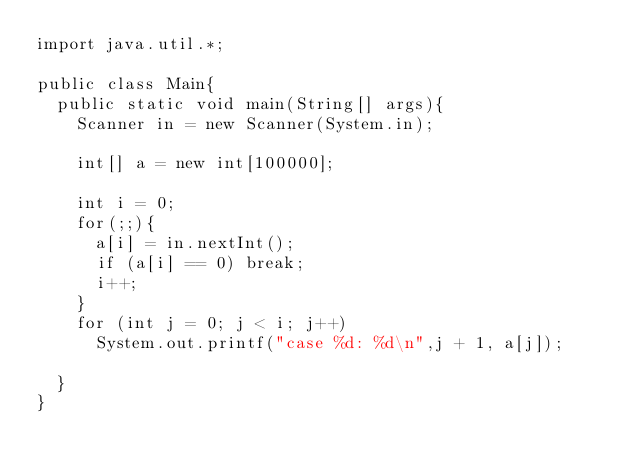<code> <loc_0><loc_0><loc_500><loc_500><_Java_>import java.util.*;

public class Main{
  public static void main(String[] args){
    Scanner in = new Scanner(System.in);

    int[] a = new int[100000];

    int i = 0;
    for(;;){
      a[i] = in.nextInt();
      if (a[i] == 0) break;
      i++;
    }
    for (int j = 0; j < i; j++)
      System.out.printf("case %d: %d\n",j + 1, a[j]);

  }
}</code> 